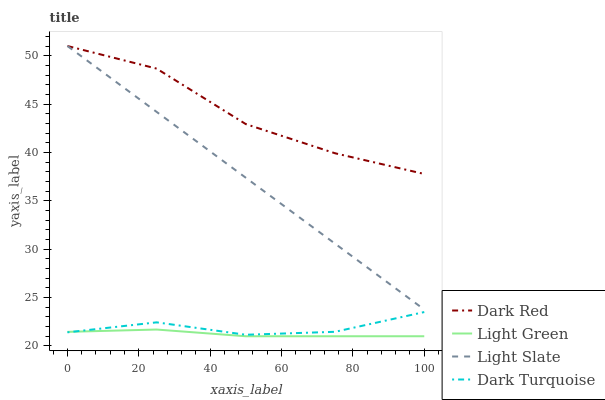Does Light Green have the minimum area under the curve?
Answer yes or no. Yes. Does Dark Red have the maximum area under the curve?
Answer yes or no. Yes. Does Dark Red have the minimum area under the curve?
Answer yes or no. No. Does Light Green have the maximum area under the curve?
Answer yes or no. No. Is Light Slate the smoothest?
Answer yes or no. Yes. Is Dark Red the roughest?
Answer yes or no. Yes. Is Light Green the smoothest?
Answer yes or no. No. Is Light Green the roughest?
Answer yes or no. No. Does Light Green have the lowest value?
Answer yes or no. Yes. Does Dark Red have the lowest value?
Answer yes or no. No. Does Dark Red have the highest value?
Answer yes or no. Yes. Does Light Green have the highest value?
Answer yes or no. No. Is Dark Turquoise less than Dark Red?
Answer yes or no. Yes. Is Dark Red greater than Dark Turquoise?
Answer yes or no. Yes. Does Light Slate intersect Dark Red?
Answer yes or no. Yes. Is Light Slate less than Dark Red?
Answer yes or no. No. Is Light Slate greater than Dark Red?
Answer yes or no. No. Does Dark Turquoise intersect Dark Red?
Answer yes or no. No. 